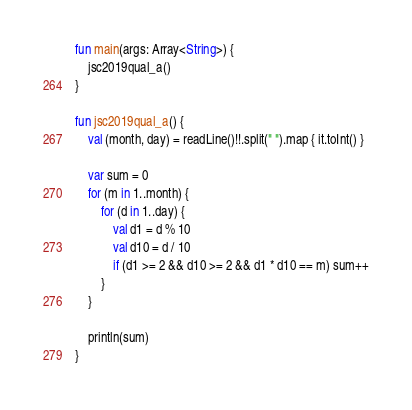<code> <loc_0><loc_0><loc_500><loc_500><_Kotlin_>fun main(args: Array<String>) {
    jsc2019qual_a()
}

fun jsc2019qual_a() {
    val (month, day) = readLine()!!.split(" ").map { it.toInt() }

    var sum = 0
    for (m in 1..month) {
        for (d in 1..day) {
            val d1 = d % 10
            val d10 = d / 10
            if (d1 >= 2 && d10 >= 2 && d1 * d10 == m) sum++
        }
    }

    println(sum)
}
</code> 